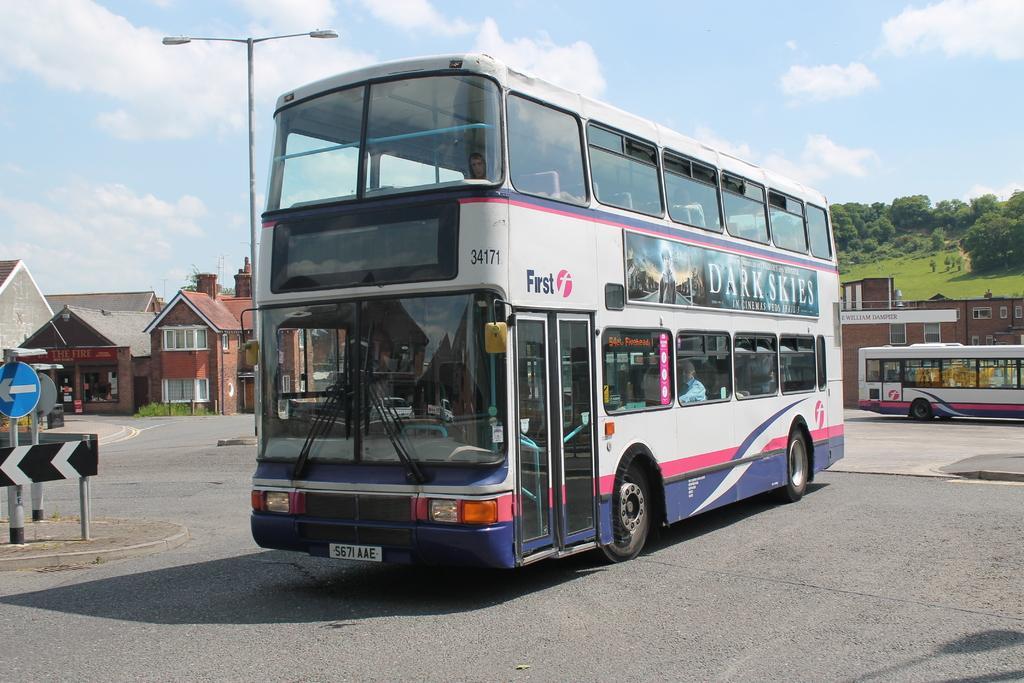Describe this image in one or two sentences. This is an outside view. Here I can see two buses on the road. I can see few people inside the bus. On the left side there are few poles on the footpath. In the background there are some houses, trees and a light pole. At the top of the image I can see the sky and clouds. 